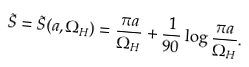Convert formula to latex. <formula><loc_0><loc_0><loc_500><loc_500>\tilde { S } = \tilde { S } ( a , \Omega _ { H } ) = \frac { \pi a } { \Omega _ { H } } + \frac { 1 } { 9 0 } \log { \frac { \pi a } { \Omega _ { H } } } .</formula> 